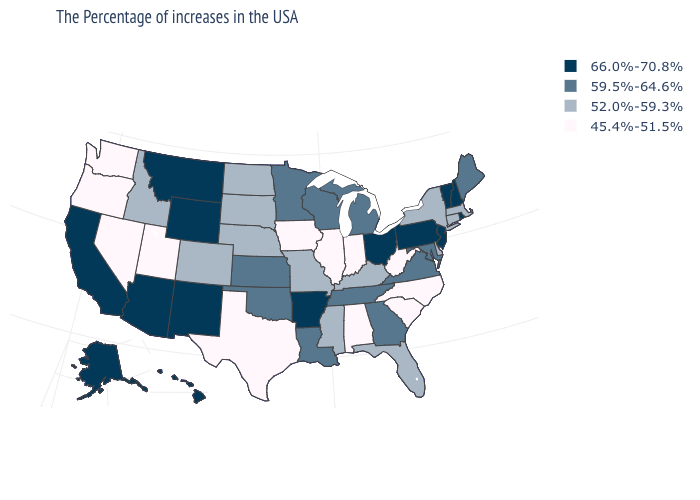Among the states that border Florida , does Georgia have the highest value?
Write a very short answer. Yes. What is the value of Nevada?
Answer briefly. 45.4%-51.5%. Name the states that have a value in the range 52.0%-59.3%?
Be succinct. Massachusetts, Connecticut, New York, Delaware, Florida, Kentucky, Mississippi, Missouri, Nebraska, South Dakota, North Dakota, Colorado, Idaho. Among the states that border Alabama , which have the lowest value?
Short answer required. Florida, Mississippi. Does the first symbol in the legend represent the smallest category?
Short answer required. No. Among the states that border Utah , does Nevada have the lowest value?
Answer briefly. Yes. What is the value of Hawaii?
Be succinct. 66.0%-70.8%. Name the states that have a value in the range 66.0%-70.8%?
Answer briefly. Rhode Island, New Hampshire, Vermont, New Jersey, Pennsylvania, Ohio, Arkansas, Wyoming, New Mexico, Montana, Arizona, California, Alaska, Hawaii. Name the states that have a value in the range 45.4%-51.5%?
Short answer required. North Carolina, South Carolina, West Virginia, Indiana, Alabama, Illinois, Iowa, Texas, Utah, Nevada, Washington, Oregon. Does the first symbol in the legend represent the smallest category?
Give a very brief answer. No. Name the states that have a value in the range 66.0%-70.8%?
Write a very short answer. Rhode Island, New Hampshire, Vermont, New Jersey, Pennsylvania, Ohio, Arkansas, Wyoming, New Mexico, Montana, Arizona, California, Alaska, Hawaii. Does South Carolina have the same value as Indiana?
Write a very short answer. Yes. What is the highest value in the West ?
Give a very brief answer. 66.0%-70.8%. Is the legend a continuous bar?
Quick response, please. No. What is the value of New Mexico?
Write a very short answer. 66.0%-70.8%. 